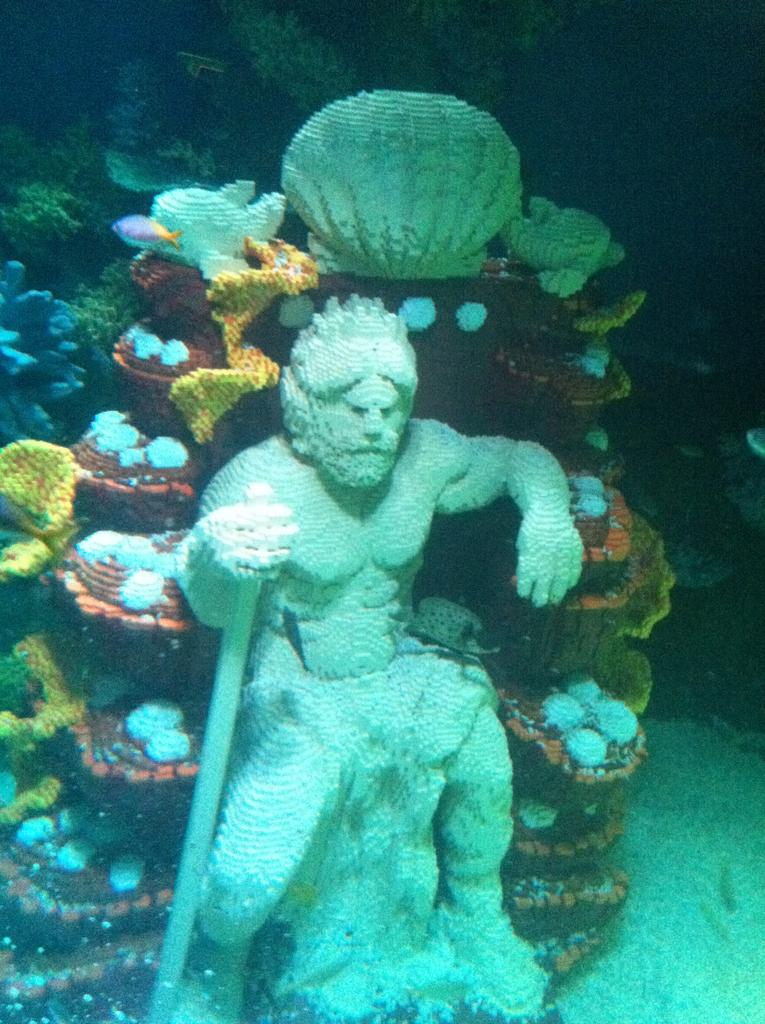Where was the image taken? The image was taken underwater. What can be seen in the foreground of the image? There is a statue of a person in the image. What can be seen in the background of the image? There are marine species visible in the background of the image. What type of rhythm can be heard coming from the statue in the image? There is no sound or rhythm present in the image, as it is a still photograph taken underwater. 